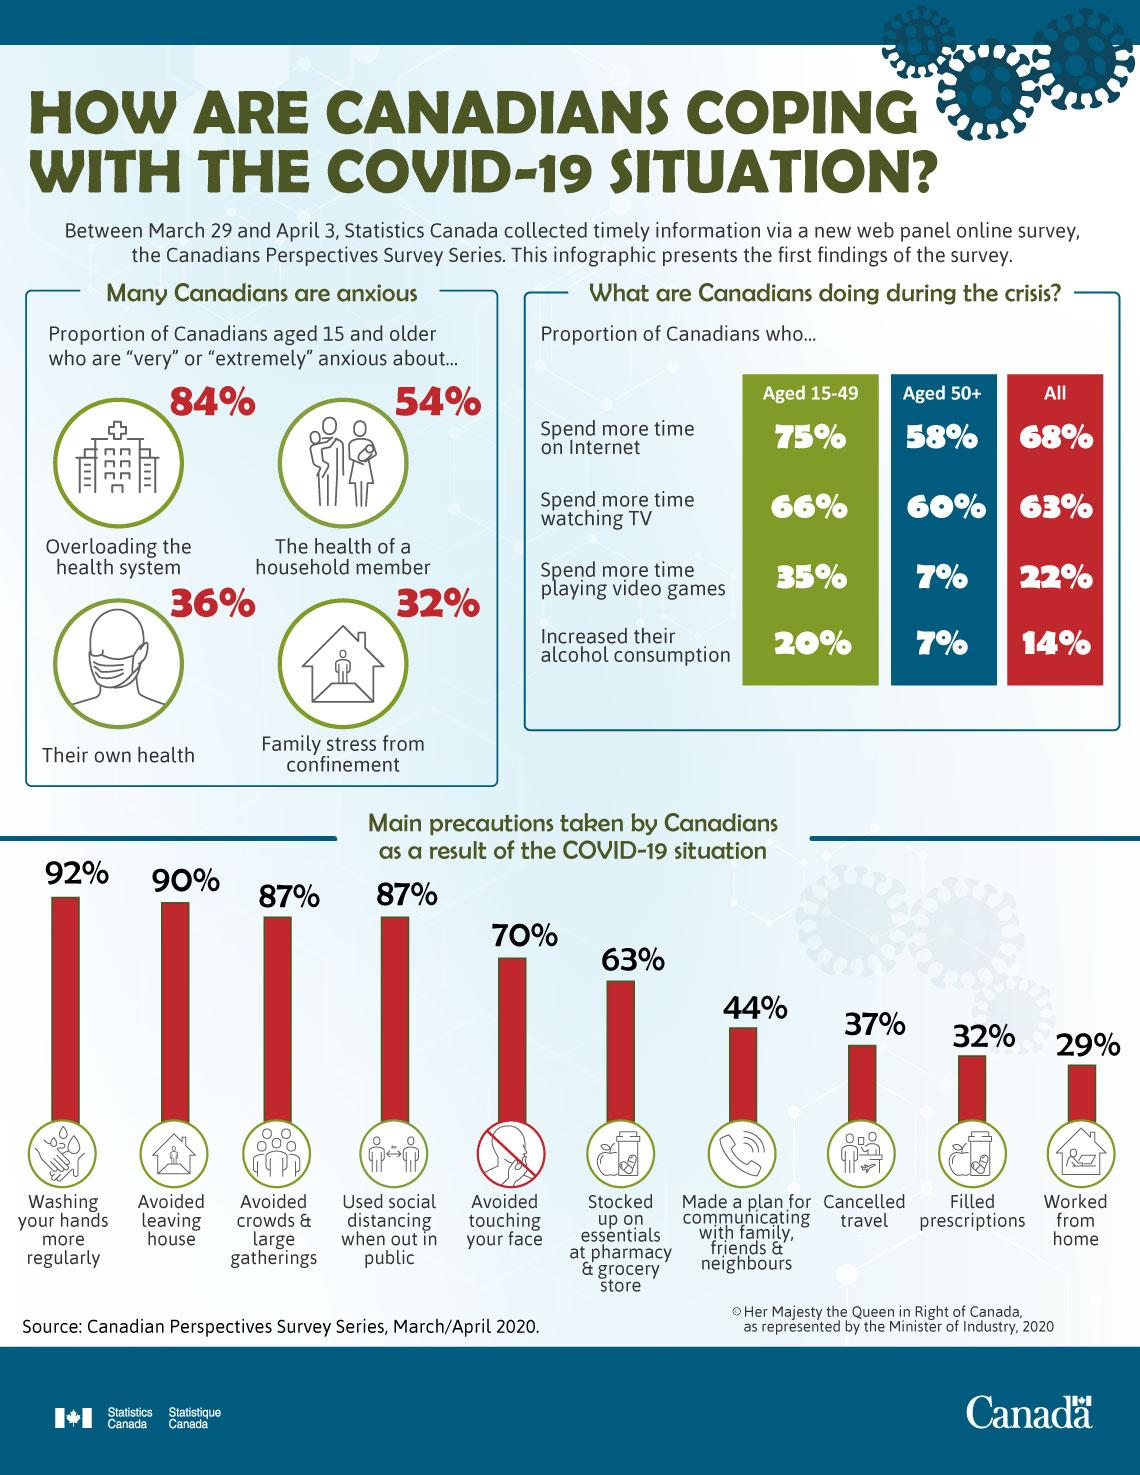Point out several critical features in this image. In response to the COVID-19 pandemic, 29% of Canadians worked from home. According to a survey, 54% of Canadians aged 15 years and older reported being very anxious about the health of a household member during the COVID-19 period. According to a recent survey, 68% of Canadians reported spending more time on the internet during the COVID-19 pandemic. According to a survey, 60% of Canadians aged 50 and older spent more time watching TV during the COVID-19 pandemic period. According to a survey, 35% of Canadians aged 15-49 years have spent more time playing videos during the COVID-19 period. 